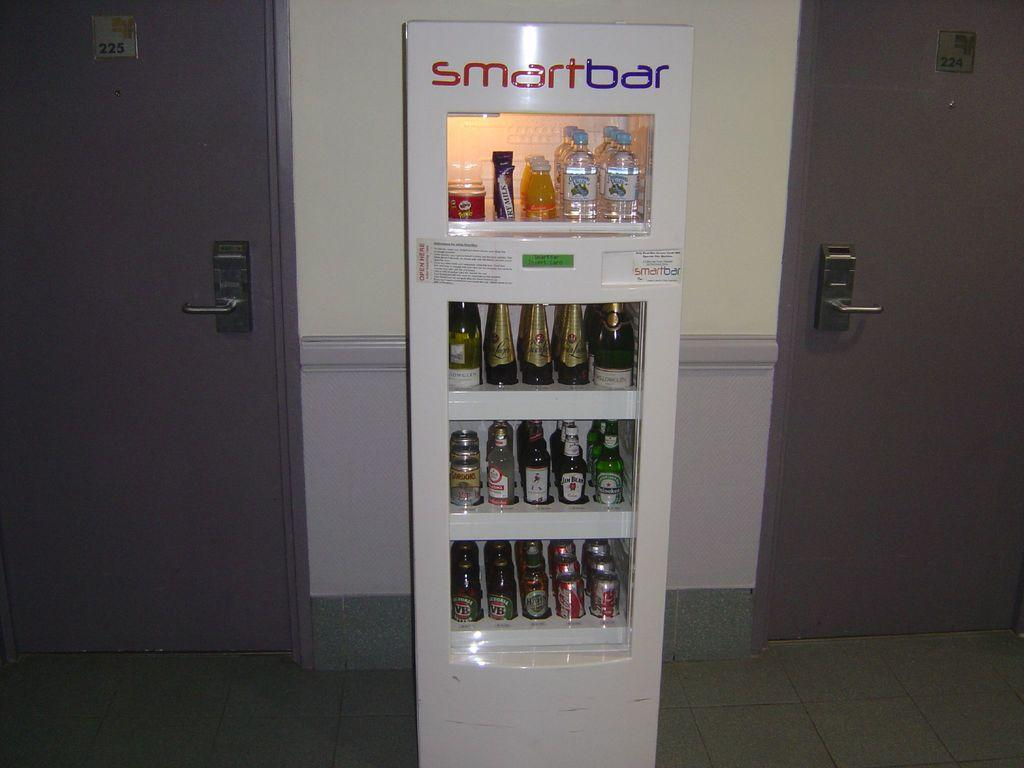<image>
Render a clear and concise summary of the photo. A vending machine bar selling alcohol known as Smartbar. 